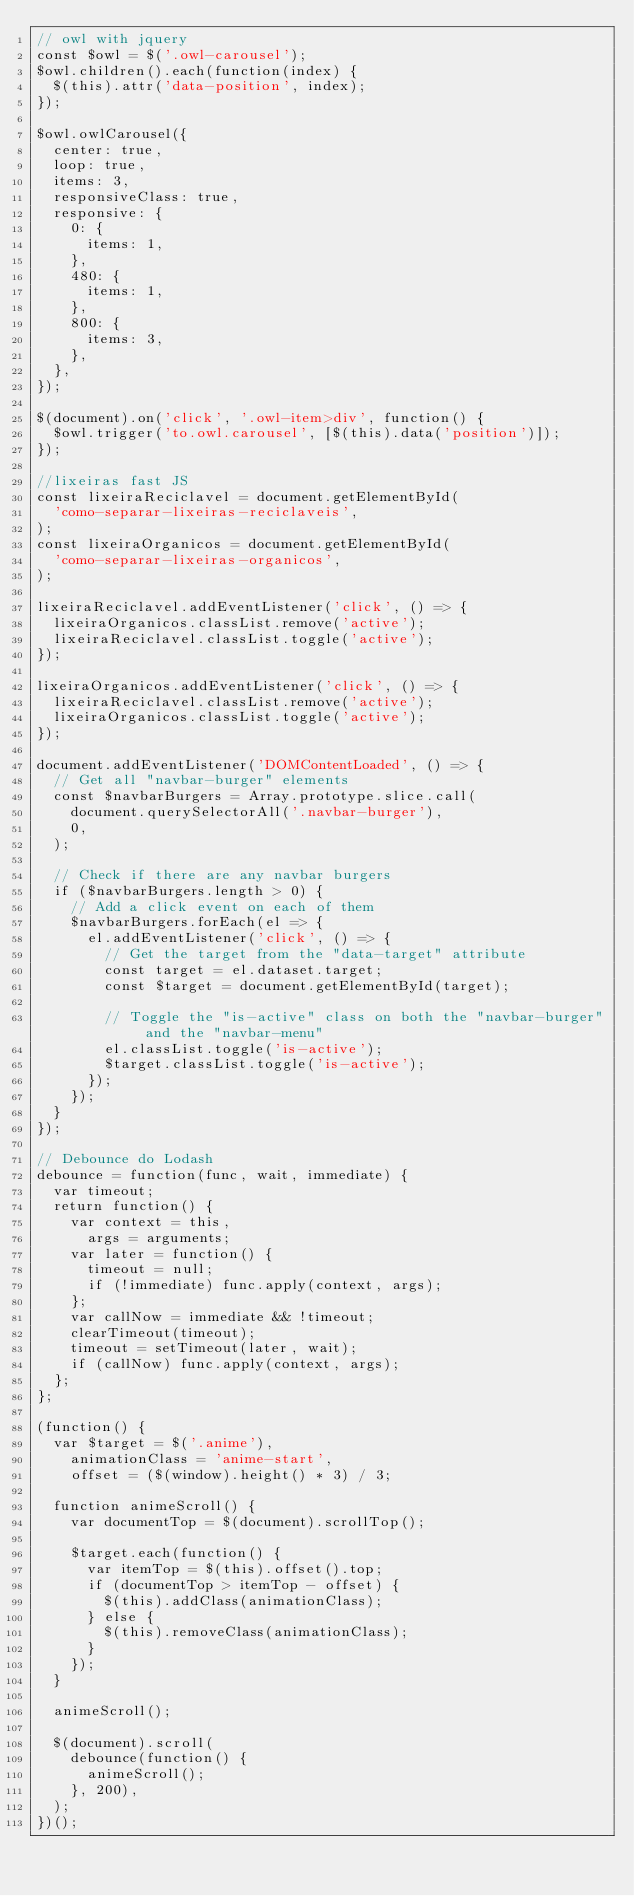<code> <loc_0><loc_0><loc_500><loc_500><_JavaScript_>// owl with jquery
const $owl = $('.owl-carousel');
$owl.children().each(function(index) {
  $(this).attr('data-position', index);
});

$owl.owlCarousel({
  center: true,
  loop: true,
  items: 3,
  responsiveClass: true,
  responsive: {
    0: {
      items: 1,
    },
    480: {
      items: 1,
    },
    800: {
      items: 3,
    },
  },
});

$(document).on('click', '.owl-item>div', function() {
  $owl.trigger('to.owl.carousel', [$(this).data('position')]);
});

//lixeiras fast JS
const lixeiraReciclavel = document.getElementById(
  'como-separar-lixeiras-reciclaveis',
);
const lixeiraOrganicos = document.getElementById(
  'como-separar-lixeiras-organicos',
);

lixeiraReciclavel.addEventListener('click', () => {
  lixeiraOrganicos.classList.remove('active');
  lixeiraReciclavel.classList.toggle('active');
});

lixeiraOrganicos.addEventListener('click', () => {
  lixeiraReciclavel.classList.remove('active');
  lixeiraOrganicos.classList.toggle('active');
});

document.addEventListener('DOMContentLoaded', () => {
  // Get all "navbar-burger" elements
  const $navbarBurgers = Array.prototype.slice.call(
    document.querySelectorAll('.navbar-burger'),
    0,
  );

  // Check if there are any navbar burgers
  if ($navbarBurgers.length > 0) {
    // Add a click event on each of them
    $navbarBurgers.forEach(el => {
      el.addEventListener('click', () => {
        // Get the target from the "data-target" attribute
        const target = el.dataset.target;
        const $target = document.getElementById(target);

        // Toggle the "is-active" class on both the "navbar-burger" and the "navbar-menu"
        el.classList.toggle('is-active');
        $target.classList.toggle('is-active');
      });
    });
  }
});

// Debounce do Lodash
debounce = function(func, wait, immediate) {
  var timeout;
  return function() {
    var context = this,
      args = arguments;
    var later = function() {
      timeout = null;
      if (!immediate) func.apply(context, args);
    };
    var callNow = immediate && !timeout;
    clearTimeout(timeout);
    timeout = setTimeout(later, wait);
    if (callNow) func.apply(context, args);
  };
};

(function() {
  var $target = $('.anime'),
    animationClass = 'anime-start',
    offset = ($(window).height() * 3) / 3;

  function animeScroll() {
    var documentTop = $(document).scrollTop();

    $target.each(function() {
      var itemTop = $(this).offset().top;
      if (documentTop > itemTop - offset) {
        $(this).addClass(animationClass);
      } else {
        $(this).removeClass(animationClass);
      }
    });
  }

  animeScroll();

  $(document).scroll(
    debounce(function() {
      animeScroll();
    }, 200),
  );
})();
</code> 